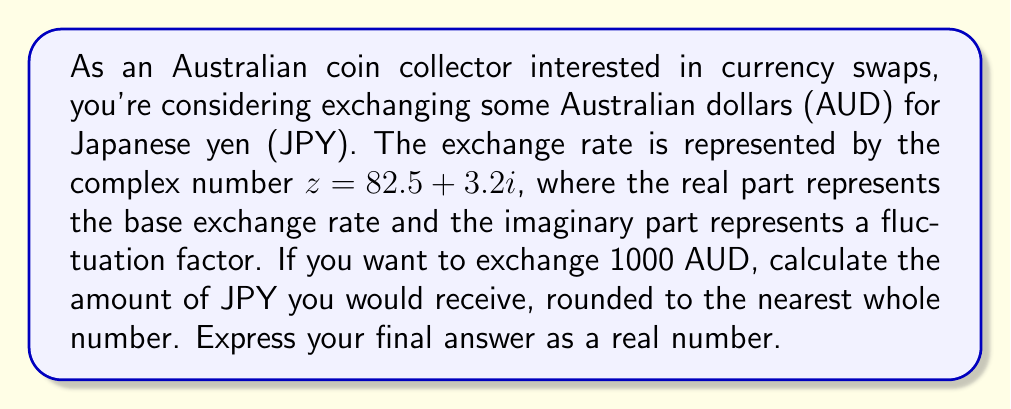Help me with this question. To solve this problem, we'll follow these steps:

1) The complex number $z = 82.5 + 3.2i$ represents the exchange rate from AUD to JPY.

2) To calculate the amount of JPY for 1000 AUD, we need to multiply 1000 by this complex number:

   $1000 \cdot (82.5 + 3.2i) = 82500 + 3200i$

3) This result is a complex number, but we need a real number for the actual currency exchange. In complex analysis, the magnitude (or modulus) of a complex number represents its "size" in the complex plane. We can interpret this magnitude as the actual exchange rate.

4) The magnitude of a complex number $a + bi$ is given by $\sqrt{a^2 + b^2}$. Let's call our result $w = 82500 + 3200i$. Then:

   $|w| = \sqrt{82500^2 + 3200^2}$

5) Let's calculate this:
   
   $|w| = \sqrt{6806250000 + 10240000} = \sqrt{6816490000} \approx 82562.47$

6) Rounding to the nearest whole number:

   82562 JPY

Thus, exchanging 1000 AUD would yield approximately 82562 JPY.
Answer: 82562 JPY 